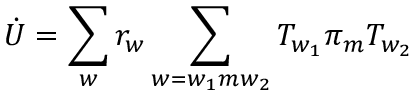Convert formula to latex. <formula><loc_0><loc_0><loc_500><loc_500>\dot { U } = \sum _ { w } r _ { w } \sum _ { w = w _ { 1 } m w _ { 2 } } T _ { w _ { 1 } } \pi _ { m } T _ { w _ { 2 } }</formula> 